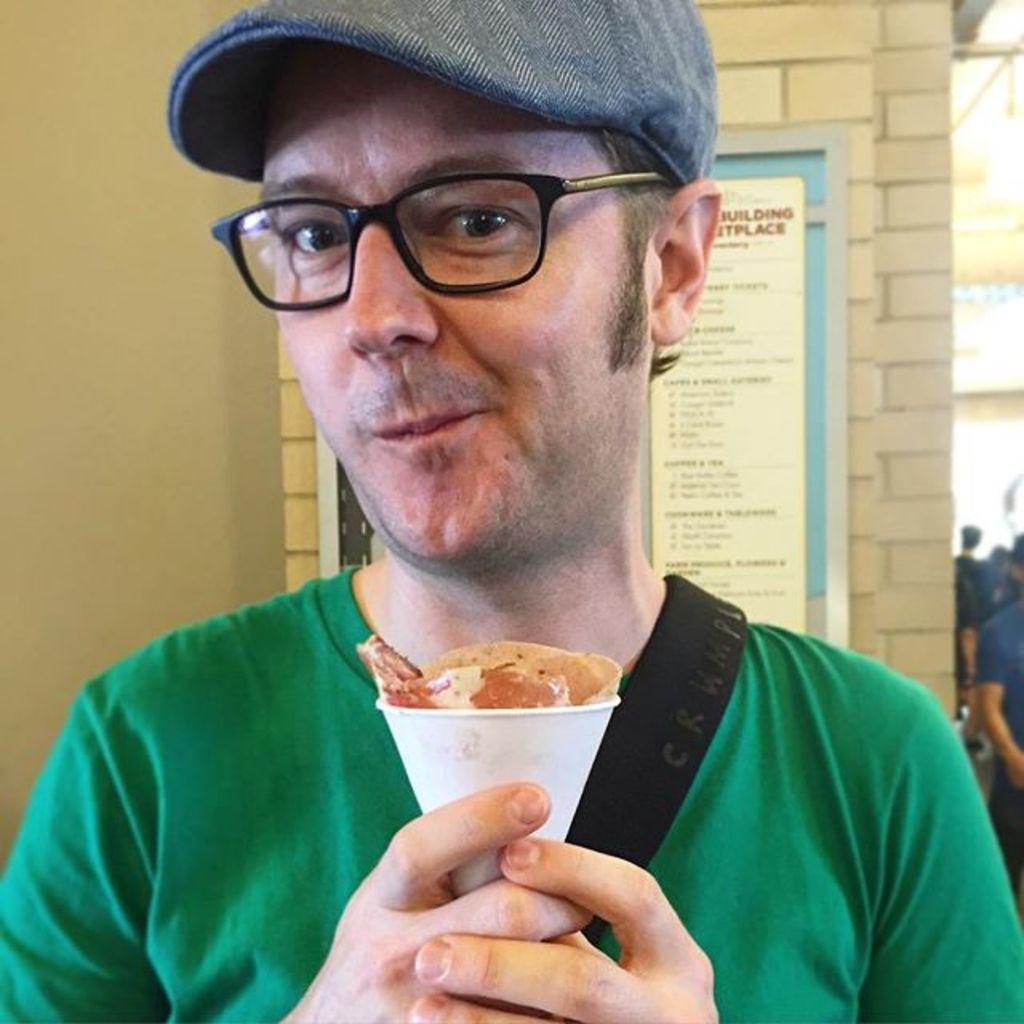What is the main subject of the image? The main subject of the image is a man. Can you describe the man's clothing in the image? The man is wearing a green T-shirt in the image. What accessories is the man wearing in the image? The man is wearing spectacles and a cap on his head in the image. What is the man holding in the image? The man is holding a cup in his hand in the image. What can be seen in the background of the image? There is a wall in the background of the image. What type of board is the man using to surf in the image? There is no board or surfing activity present in the image; the man is simply holding a cup. 